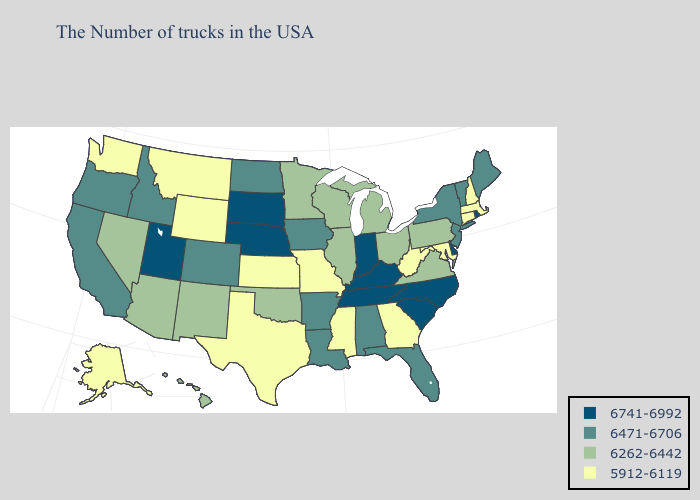What is the lowest value in the USA?
Write a very short answer. 5912-6119. What is the value of Georgia?
Be succinct. 5912-6119. What is the lowest value in the Northeast?
Keep it brief. 5912-6119. Among the states that border Wisconsin , does Michigan have the highest value?
Write a very short answer. No. What is the value of North Carolina?
Keep it brief. 6741-6992. What is the value of Arizona?
Be succinct. 6262-6442. Which states hav the highest value in the MidWest?
Concise answer only. Indiana, Nebraska, South Dakota. What is the highest value in the Northeast ?
Give a very brief answer. 6741-6992. Name the states that have a value in the range 5912-6119?
Be succinct. Massachusetts, New Hampshire, Connecticut, Maryland, West Virginia, Georgia, Mississippi, Missouri, Kansas, Texas, Wyoming, Montana, Washington, Alaska. What is the lowest value in states that border Georgia?
Be succinct. 6471-6706. What is the value of Georgia?
Short answer required. 5912-6119. What is the value of Hawaii?
Concise answer only. 6262-6442. What is the highest value in states that border Alabama?
Concise answer only. 6741-6992. Which states have the highest value in the USA?
Short answer required. Rhode Island, Delaware, North Carolina, South Carolina, Kentucky, Indiana, Tennessee, Nebraska, South Dakota, Utah. Does the first symbol in the legend represent the smallest category?
Keep it brief. No. 